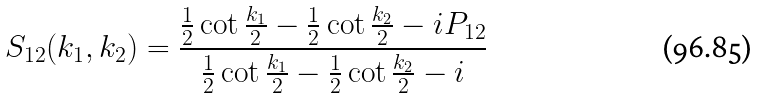<formula> <loc_0><loc_0><loc_500><loc_500>S _ { 1 2 } ( k _ { 1 } , k _ { 2 } ) = \frac { \frac { 1 } { 2 } \cot \frac { k _ { 1 } } 2 - \frac { 1 } { 2 } \cot \frac { k _ { 2 } } 2 - i P _ { 1 2 } } { \frac { 1 } { 2 } \cot \frac { k _ { 1 } } 2 - \frac { 1 } { 2 } \cot \frac { k _ { 2 } } 2 - i }</formula> 